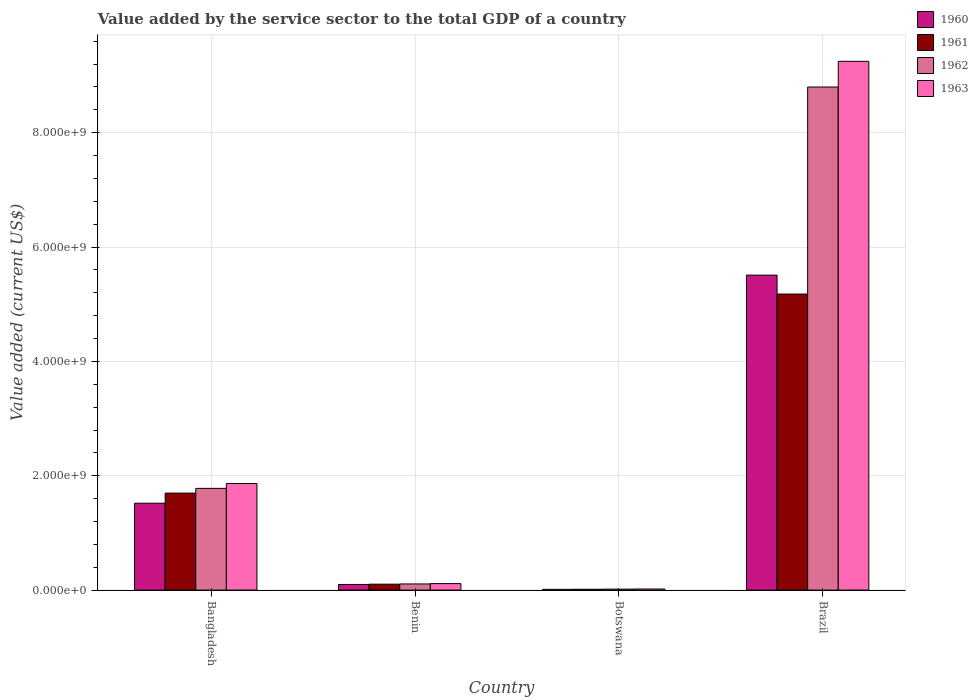How many different coloured bars are there?
Your response must be concise. 4. How many bars are there on the 4th tick from the left?
Keep it short and to the point. 4. What is the label of the 3rd group of bars from the left?
Your answer should be very brief. Botswana. What is the value added by the service sector to the total GDP in 1961 in Botswana?
Offer a terse response. 1.51e+07. Across all countries, what is the maximum value added by the service sector to the total GDP in 1963?
Keep it short and to the point. 9.25e+09. Across all countries, what is the minimum value added by the service sector to the total GDP in 1961?
Provide a succinct answer. 1.51e+07. In which country was the value added by the service sector to the total GDP in 1960 maximum?
Provide a short and direct response. Brazil. In which country was the value added by the service sector to the total GDP in 1962 minimum?
Give a very brief answer. Botswana. What is the total value added by the service sector to the total GDP in 1961 in the graph?
Make the answer very short. 6.99e+09. What is the difference between the value added by the service sector to the total GDP in 1960 in Botswana and that in Brazil?
Provide a succinct answer. -5.50e+09. What is the difference between the value added by the service sector to the total GDP in 1963 in Botswana and the value added by the service sector to the total GDP in 1960 in Brazil?
Make the answer very short. -5.49e+09. What is the average value added by the service sector to the total GDP in 1960 per country?
Your answer should be compact. 1.79e+09. What is the difference between the value added by the service sector to the total GDP of/in 1962 and value added by the service sector to the total GDP of/in 1963 in Benin?
Keep it short and to the point. -6.21e+06. In how many countries, is the value added by the service sector to the total GDP in 1961 greater than 400000000 US$?
Make the answer very short. 2. What is the ratio of the value added by the service sector to the total GDP in 1963 in Bangladesh to that in Botswana?
Make the answer very short. 96.85. Is the value added by the service sector to the total GDP in 1962 in Benin less than that in Botswana?
Your answer should be very brief. No. What is the difference between the highest and the second highest value added by the service sector to the total GDP in 1960?
Ensure brevity in your answer.  5.41e+09. What is the difference between the highest and the lowest value added by the service sector to the total GDP in 1961?
Keep it short and to the point. 5.16e+09. What does the 2nd bar from the left in Bangladesh represents?
Provide a short and direct response. 1961. How many bars are there?
Keep it short and to the point. 16. Are all the bars in the graph horizontal?
Provide a succinct answer. No. How many countries are there in the graph?
Ensure brevity in your answer.  4. What is the difference between two consecutive major ticks on the Y-axis?
Your response must be concise. 2.00e+09. Does the graph contain any zero values?
Offer a terse response. No. How many legend labels are there?
Offer a very short reply. 4. What is the title of the graph?
Your response must be concise. Value added by the service sector to the total GDP of a country. What is the label or title of the Y-axis?
Provide a short and direct response. Value added (current US$). What is the Value added (current US$) of 1960 in Bangladesh?
Offer a terse response. 1.52e+09. What is the Value added (current US$) in 1961 in Bangladesh?
Your answer should be compact. 1.70e+09. What is the Value added (current US$) in 1962 in Bangladesh?
Provide a succinct answer. 1.78e+09. What is the Value added (current US$) in 1963 in Bangladesh?
Offer a very short reply. 1.86e+09. What is the Value added (current US$) in 1960 in Benin?
Make the answer very short. 9.87e+07. What is the Value added (current US$) of 1961 in Benin?
Your response must be concise. 1.04e+08. What is the Value added (current US$) in 1962 in Benin?
Your response must be concise. 1.08e+08. What is the Value added (current US$) of 1963 in Benin?
Give a very brief answer. 1.14e+08. What is the Value added (current US$) in 1960 in Botswana?
Offer a terse response. 1.31e+07. What is the Value added (current US$) of 1961 in Botswana?
Provide a succinct answer. 1.51e+07. What is the Value added (current US$) of 1962 in Botswana?
Provide a short and direct response. 1.73e+07. What is the Value added (current US$) of 1963 in Botswana?
Your answer should be very brief. 1.93e+07. What is the Value added (current US$) in 1960 in Brazil?
Give a very brief answer. 5.51e+09. What is the Value added (current US$) in 1961 in Brazil?
Provide a succinct answer. 5.18e+09. What is the Value added (current US$) of 1962 in Brazil?
Keep it short and to the point. 8.80e+09. What is the Value added (current US$) in 1963 in Brazil?
Provide a succinct answer. 9.25e+09. Across all countries, what is the maximum Value added (current US$) of 1960?
Your answer should be compact. 5.51e+09. Across all countries, what is the maximum Value added (current US$) of 1961?
Your answer should be compact. 5.18e+09. Across all countries, what is the maximum Value added (current US$) in 1962?
Give a very brief answer. 8.80e+09. Across all countries, what is the maximum Value added (current US$) of 1963?
Offer a very short reply. 9.25e+09. Across all countries, what is the minimum Value added (current US$) in 1960?
Provide a short and direct response. 1.31e+07. Across all countries, what is the minimum Value added (current US$) in 1961?
Your answer should be compact. 1.51e+07. Across all countries, what is the minimum Value added (current US$) in 1962?
Your answer should be very brief. 1.73e+07. Across all countries, what is the minimum Value added (current US$) in 1963?
Provide a short and direct response. 1.93e+07. What is the total Value added (current US$) of 1960 in the graph?
Provide a succinct answer. 7.14e+09. What is the total Value added (current US$) of 1961 in the graph?
Offer a terse response. 6.99e+09. What is the total Value added (current US$) in 1962 in the graph?
Keep it short and to the point. 1.07e+1. What is the total Value added (current US$) of 1963 in the graph?
Keep it short and to the point. 1.12e+1. What is the difference between the Value added (current US$) in 1960 in Bangladesh and that in Benin?
Make the answer very short. 1.42e+09. What is the difference between the Value added (current US$) in 1961 in Bangladesh and that in Benin?
Offer a very short reply. 1.59e+09. What is the difference between the Value added (current US$) in 1962 in Bangladesh and that in Benin?
Ensure brevity in your answer.  1.67e+09. What is the difference between the Value added (current US$) in 1963 in Bangladesh and that in Benin?
Provide a short and direct response. 1.75e+09. What is the difference between the Value added (current US$) in 1960 in Bangladesh and that in Botswana?
Give a very brief answer. 1.51e+09. What is the difference between the Value added (current US$) of 1961 in Bangladesh and that in Botswana?
Give a very brief answer. 1.68e+09. What is the difference between the Value added (current US$) of 1962 in Bangladesh and that in Botswana?
Your response must be concise. 1.76e+09. What is the difference between the Value added (current US$) of 1963 in Bangladesh and that in Botswana?
Offer a very short reply. 1.85e+09. What is the difference between the Value added (current US$) of 1960 in Bangladesh and that in Brazil?
Offer a very short reply. -3.99e+09. What is the difference between the Value added (current US$) of 1961 in Bangladesh and that in Brazil?
Keep it short and to the point. -3.48e+09. What is the difference between the Value added (current US$) of 1962 in Bangladesh and that in Brazil?
Keep it short and to the point. -7.02e+09. What is the difference between the Value added (current US$) of 1963 in Bangladesh and that in Brazil?
Your response must be concise. -7.38e+09. What is the difference between the Value added (current US$) of 1960 in Benin and that in Botswana?
Provide a short and direct response. 8.55e+07. What is the difference between the Value added (current US$) of 1961 in Benin and that in Botswana?
Give a very brief answer. 8.86e+07. What is the difference between the Value added (current US$) of 1962 in Benin and that in Botswana?
Offer a very short reply. 9.03e+07. What is the difference between the Value added (current US$) of 1963 in Benin and that in Botswana?
Your answer should be very brief. 9.45e+07. What is the difference between the Value added (current US$) of 1960 in Benin and that in Brazil?
Offer a terse response. -5.41e+09. What is the difference between the Value added (current US$) in 1961 in Benin and that in Brazil?
Give a very brief answer. -5.07e+09. What is the difference between the Value added (current US$) in 1962 in Benin and that in Brazil?
Your answer should be very brief. -8.69e+09. What is the difference between the Value added (current US$) of 1963 in Benin and that in Brazil?
Your response must be concise. -9.13e+09. What is the difference between the Value added (current US$) of 1960 in Botswana and that in Brazil?
Make the answer very short. -5.50e+09. What is the difference between the Value added (current US$) in 1961 in Botswana and that in Brazil?
Provide a succinct answer. -5.16e+09. What is the difference between the Value added (current US$) in 1962 in Botswana and that in Brazil?
Keep it short and to the point. -8.78e+09. What is the difference between the Value added (current US$) of 1963 in Botswana and that in Brazil?
Give a very brief answer. -9.23e+09. What is the difference between the Value added (current US$) in 1960 in Bangladesh and the Value added (current US$) in 1961 in Benin?
Your answer should be compact. 1.42e+09. What is the difference between the Value added (current US$) in 1960 in Bangladesh and the Value added (current US$) in 1962 in Benin?
Your answer should be very brief. 1.41e+09. What is the difference between the Value added (current US$) of 1960 in Bangladesh and the Value added (current US$) of 1963 in Benin?
Provide a short and direct response. 1.41e+09. What is the difference between the Value added (current US$) in 1961 in Bangladesh and the Value added (current US$) in 1962 in Benin?
Keep it short and to the point. 1.59e+09. What is the difference between the Value added (current US$) in 1961 in Bangladesh and the Value added (current US$) in 1963 in Benin?
Keep it short and to the point. 1.58e+09. What is the difference between the Value added (current US$) of 1962 in Bangladesh and the Value added (current US$) of 1963 in Benin?
Provide a short and direct response. 1.67e+09. What is the difference between the Value added (current US$) in 1960 in Bangladesh and the Value added (current US$) in 1961 in Botswana?
Ensure brevity in your answer.  1.50e+09. What is the difference between the Value added (current US$) in 1960 in Bangladesh and the Value added (current US$) in 1962 in Botswana?
Offer a terse response. 1.50e+09. What is the difference between the Value added (current US$) of 1960 in Bangladesh and the Value added (current US$) of 1963 in Botswana?
Provide a short and direct response. 1.50e+09. What is the difference between the Value added (current US$) in 1961 in Bangladesh and the Value added (current US$) in 1962 in Botswana?
Make the answer very short. 1.68e+09. What is the difference between the Value added (current US$) of 1961 in Bangladesh and the Value added (current US$) of 1963 in Botswana?
Your response must be concise. 1.68e+09. What is the difference between the Value added (current US$) of 1962 in Bangladesh and the Value added (current US$) of 1963 in Botswana?
Your answer should be compact. 1.76e+09. What is the difference between the Value added (current US$) of 1960 in Bangladesh and the Value added (current US$) of 1961 in Brazil?
Your response must be concise. -3.66e+09. What is the difference between the Value added (current US$) in 1960 in Bangladesh and the Value added (current US$) in 1962 in Brazil?
Ensure brevity in your answer.  -7.28e+09. What is the difference between the Value added (current US$) of 1960 in Bangladesh and the Value added (current US$) of 1963 in Brazil?
Give a very brief answer. -7.73e+09. What is the difference between the Value added (current US$) of 1961 in Bangladesh and the Value added (current US$) of 1962 in Brazil?
Your answer should be very brief. -7.10e+09. What is the difference between the Value added (current US$) of 1961 in Bangladesh and the Value added (current US$) of 1963 in Brazil?
Your answer should be very brief. -7.55e+09. What is the difference between the Value added (current US$) of 1962 in Bangladesh and the Value added (current US$) of 1963 in Brazil?
Your answer should be very brief. -7.47e+09. What is the difference between the Value added (current US$) in 1960 in Benin and the Value added (current US$) in 1961 in Botswana?
Offer a very short reply. 8.36e+07. What is the difference between the Value added (current US$) of 1960 in Benin and the Value added (current US$) of 1962 in Botswana?
Keep it short and to the point. 8.14e+07. What is the difference between the Value added (current US$) in 1960 in Benin and the Value added (current US$) in 1963 in Botswana?
Give a very brief answer. 7.94e+07. What is the difference between the Value added (current US$) in 1961 in Benin and the Value added (current US$) in 1962 in Botswana?
Give a very brief answer. 8.64e+07. What is the difference between the Value added (current US$) in 1961 in Benin and the Value added (current US$) in 1963 in Botswana?
Your answer should be very brief. 8.44e+07. What is the difference between the Value added (current US$) of 1962 in Benin and the Value added (current US$) of 1963 in Botswana?
Give a very brief answer. 8.83e+07. What is the difference between the Value added (current US$) in 1960 in Benin and the Value added (current US$) in 1961 in Brazil?
Provide a succinct answer. -5.08e+09. What is the difference between the Value added (current US$) in 1960 in Benin and the Value added (current US$) in 1962 in Brazil?
Provide a succinct answer. -8.70e+09. What is the difference between the Value added (current US$) of 1960 in Benin and the Value added (current US$) of 1963 in Brazil?
Keep it short and to the point. -9.15e+09. What is the difference between the Value added (current US$) in 1961 in Benin and the Value added (current US$) in 1962 in Brazil?
Provide a succinct answer. -8.70e+09. What is the difference between the Value added (current US$) of 1961 in Benin and the Value added (current US$) of 1963 in Brazil?
Your response must be concise. -9.14e+09. What is the difference between the Value added (current US$) in 1962 in Benin and the Value added (current US$) in 1963 in Brazil?
Offer a very short reply. -9.14e+09. What is the difference between the Value added (current US$) in 1960 in Botswana and the Value added (current US$) in 1961 in Brazil?
Give a very brief answer. -5.17e+09. What is the difference between the Value added (current US$) of 1960 in Botswana and the Value added (current US$) of 1962 in Brazil?
Provide a short and direct response. -8.79e+09. What is the difference between the Value added (current US$) of 1960 in Botswana and the Value added (current US$) of 1963 in Brazil?
Your response must be concise. -9.24e+09. What is the difference between the Value added (current US$) of 1961 in Botswana and the Value added (current US$) of 1962 in Brazil?
Your answer should be compact. -8.78e+09. What is the difference between the Value added (current US$) in 1961 in Botswana and the Value added (current US$) in 1963 in Brazil?
Give a very brief answer. -9.23e+09. What is the difference between the Value added (current US$) in 1962 in Botswana and the Value added (current US$) in 1963 in Brazil?
Your answer should be very brief. -9.23e+09. What is the average Value added (current US$) in 1960 per country?
Provide a succinct answer. 1.79e+09. What is the average Value added (current US$) of 1961 per country?
Your answer should be very brief. 1.75e+09. What is the average Value added (current US$) in 1962 per country?
Your answer should be compact. 2.68e+09. What is the average Value added (current US$) in 1963 per country?
Offer a terse response. 2.81e+09. What is the difference between the Value added (current US$) of 1960 and Value added (current US$) of 1961 in Bangladesh?
Your answer should be very brief. -1.77e+08. What is the difference between the Value added (current US$) of 1960 and Value added (current US$) of 1962 in Bangladesh?
Ensure brevity in your answer.  -2.60e+08. What is the difference between the Value added (current US$) of 1960 and Value added (current US$) of 1963 in Bangladesh?
Your answer should be compact. -3.45e+08. What is the difference between the Value added (current US$) in 1961 and Value added (current US$) in 1962 in Bangladesh?
Provide a succinct answer. -8.27e+07. What is the difference between the Value added (current US$) of 1961 and Value added (current US$) of 1963 in Bangladesh?
Offer a very short reply. -1.68e+08. What is the difference between the Value added (current US$) of 1962 and Value added (current US$) of 1963 in Bangladesh?
Offer a terse response. -8.50e+07. What is the difference between the Value added (current US$) in 1960 and Value added (current US$) in 1961 in Benin?
Your answer should be very brief. -5.02e+06. What is the difference between the Value added (current US$) in 1960 and Value added (current US$) in 1962 in Benin?
Ensure brevity in your answer.  -8.92e+06. What is the difference between the Value added (current US$) of 1960 and Value added (current US$) of 1963 in Benin?
Provide a succinct answer. -1.51e+07. What is the difference between the Value added (current US$) of 1961 and Value added (current US$) of 1962 in Benin?
Your answer should be very brief. -3.90e+06. What is the difference between the Value added (current US$) in 1961 and Value added (current US$) in 1963 in Benin?
Your answer should be very brief. -1.01e+07. What is the difference between the Value added (current US$) in 1962 and Value added (current US$) in 1963 in Benin?
Your answer should be compact. -6.21e+06. What is the difference between the Value added (current US$) in 1960 and Value added (current US$) in 1961 in Botswana?
Provide a short and direct response. -1.99e+06. What is the difference between the Value added (current US$) in 1960 and Value added (current US$) in 1962 in Botswana?
Offer a very short reply. -4.17e+06. What is the difference between the Value added (current US$) in 1960 and Value added (current US$) in 1963 in Botswana?
Your answer should be very brief. -6.14e+06. What is the difference between the Value added (current US$) in 1961 and Value added (current US$) in 1962 in Botswana?
Give a very brief answer. -2.18e+06. What is the difference between the Value added (current US$) of 1961 and Value added (current US$) of 1963 in Botswana?
Offer a very short reply. -4.15e+06. What is the difference between the Value added (current US$) in 1962 and Value added (current US$) in 1963 in Botswana?
Provide a succinct answer. -1.97e+06. What is the difference between the Value added (current US$) of 1960 and Value added (current US$) of 1961 in Brazil?
Keep it short and to the point. 3.31e+08. What is the difference between the Value added (current US$) of 1960 and Value added (current US$) of 1962 in Brazil?
Ensure brevity in your answer.  -3.29e+09. What is the difference between the Value added (current US$) in 1960 and Value added (current US$) in 1963 in Brazil?
Provide a short and direct response. -3.74e+09. What is the difference between the Value added (current US$) of 1961 and Value added (current US$) of 1962 in Brazil?
Offer a very short reply. -3.62e+09. What is the difference between the Value added (current US$) of 1961 and Value added (current US$) of 1963 in Brazil?
Give a very brief answer. -4.07e+09. What is the difference between the Value added (current US$) in 1962 and Value added (current US$) in 1963 in Brazil?
Provide a succinct answer. -4.49e+08. What is the ratio of the Value added (current US$) in 1960 in Bangladesh to that in Benin?
Give a very brief answer. 15.41. What is the ratio of the Value added (current US$) in 1961 in Bangladesh to that in Benin?
Your answer should be very brief. 16.36. What is the ratio of the Value added (current US$) of 1962 in Bangladesh to that in Benin?
Offer a terse response. 16.54. What is the ratio of the Value added (current US$) in 1963 in Bangladesh to that in Benin?
Your answer should be very brief. 16.38. What is the ratio of the Value added (current US$) in 1960 in Bangladesh to that in Botswana?
Your response must be concise. 115.9. What is the ratio of the Value added (current US$) of 1961 in Bangladesh to that in Botswana?
Your answer should be very brief. 112.32. What is the ratio of the Value added (current US$) in 1962 in Bangladesh to that in Botswana?
Keep it short and to the point. 102.95. What is the ratio of the Value added (current US$) in 1963 in Bangladesh to that in Botswana?
Your answer should be very brief. 96.85. What is the ratio of the Value added (current US$) of 1960 in Bangladesh to that in Brazil?
Your answer should be very brief. 0.28. What is the ratio of the Value added (current US$) in 1961 in Bangladesh to that in Brazil?
Offer a very short reply. 0.33. What is the ratio of the Value added (current US$) in 1962 in Bangladesh to that in Brazil?
Provide a succinct answer. 0.2. What is the ratio of the Value added (current US$) of 1963 in Bangladesh to that in Brazil?
Ensure brevity in your answer.  0.2. What is the ratio of the Value added (current US$) of 1960 in Benin to that in Botswana?
Keep it short and to the point. 7.52. What is the ratio of the Value added (current US$) in 1961 in Benin to that in Botswana?
Make the answer very short. 6.86. What is the ratio of the Value added (current US$) in 1962 in Benin to that in Botswana?
Your response must be concise. 6.22. What is the ratio of the Value added (current US$) of 1963 in Benin to that in Botswana?
Offer a very short reply. 5.91. What is the ratio of the Value added (current US$) of 1960 in Benin to that in Brazil?
Give a very brief answer. 0.02. What is the ratio of the Value added (current US$) in 1961 in Benin to that in Brazil?
Your answer should be very brief. 0.02. What is the ratio of the Value added (current US$) in 1962 in Benin to that in Brazil?
Offer a very short reply. 0.01. What is the ratio of the Value added (current US$) in 1963 in Benin to that in Brazil?
Your answer should be compact. 0.01. What is the ratio of the Value added (current US$) in 1960 in Botswana to that in Brazil?
Your answer should be compact. 0. What is the ratio of the Value added (current US$) of 1961 in Botswana to that in Brazil?
Offer a very short reply. 0. What is the ratio of the Value added (current US$) in 1962 in Botswana to that in Brazil?
Your answer should be compact. 0. What is the ratio of the Value added (current US$) in 1963 in Botswana to that in Brazil?
Keep it short and to the point. 0. What is the difference between the highest and the second highest Value added (current US$) in 1960?
Make the answer very short. 3.99e+09. What is the difference between the highest and the second highest Value added (current US$) of 1961?
Your answer should be compact. 3.48e+09. What is the difference between the highest and the second highest Value added (current US$) in 1962?
Give a very brief answer. 7.02e+09. What is the difference between the highest and the second highest Value added (current US$) of 1963?
Provide a short and direct response. 7.38e+09. What is the difference between the highest and the lowest Value added (current US$) of 1960?
Make the answer very short. 5.50e+09. What is the difference between the highest and the lowest Value added (current US$) of 1961?
Your answer should be compact. 5.16e+09. What is the difference between the highest and the lowest Value added (current US$) in 1962?
Your answer should be compact. 8.78e+09. What is the difference between the highest and the lowest Value added (current US$) in 1963?
Keep it short and to the point. 9.23e+09. 